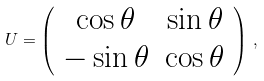<formula> <loc_0><loc_0><loc_500><loc_500>U = \left ( \begin{array} { c c } \cos \theta & \sin \theta \\ - \sin \theta & \cos \theta \end{array} \right ) \, ,</formula> 